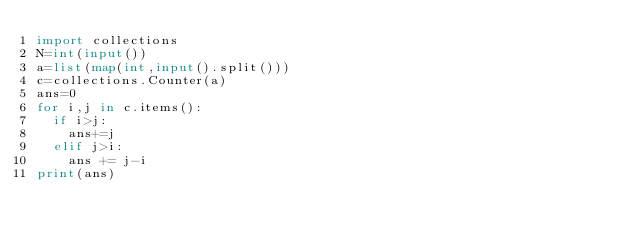Convert code to text. <code><loc_0><loc_0><loc_500><loc_500><_Python_>import collections
N=int(input())
a=list(map(int,input().split()))
c=collections.Counter(a)
ans=0
for i,j in c.items():
  if i>j:
    ans+=j
  elif j>i:
    ans += j-i
print(ans)</code> 